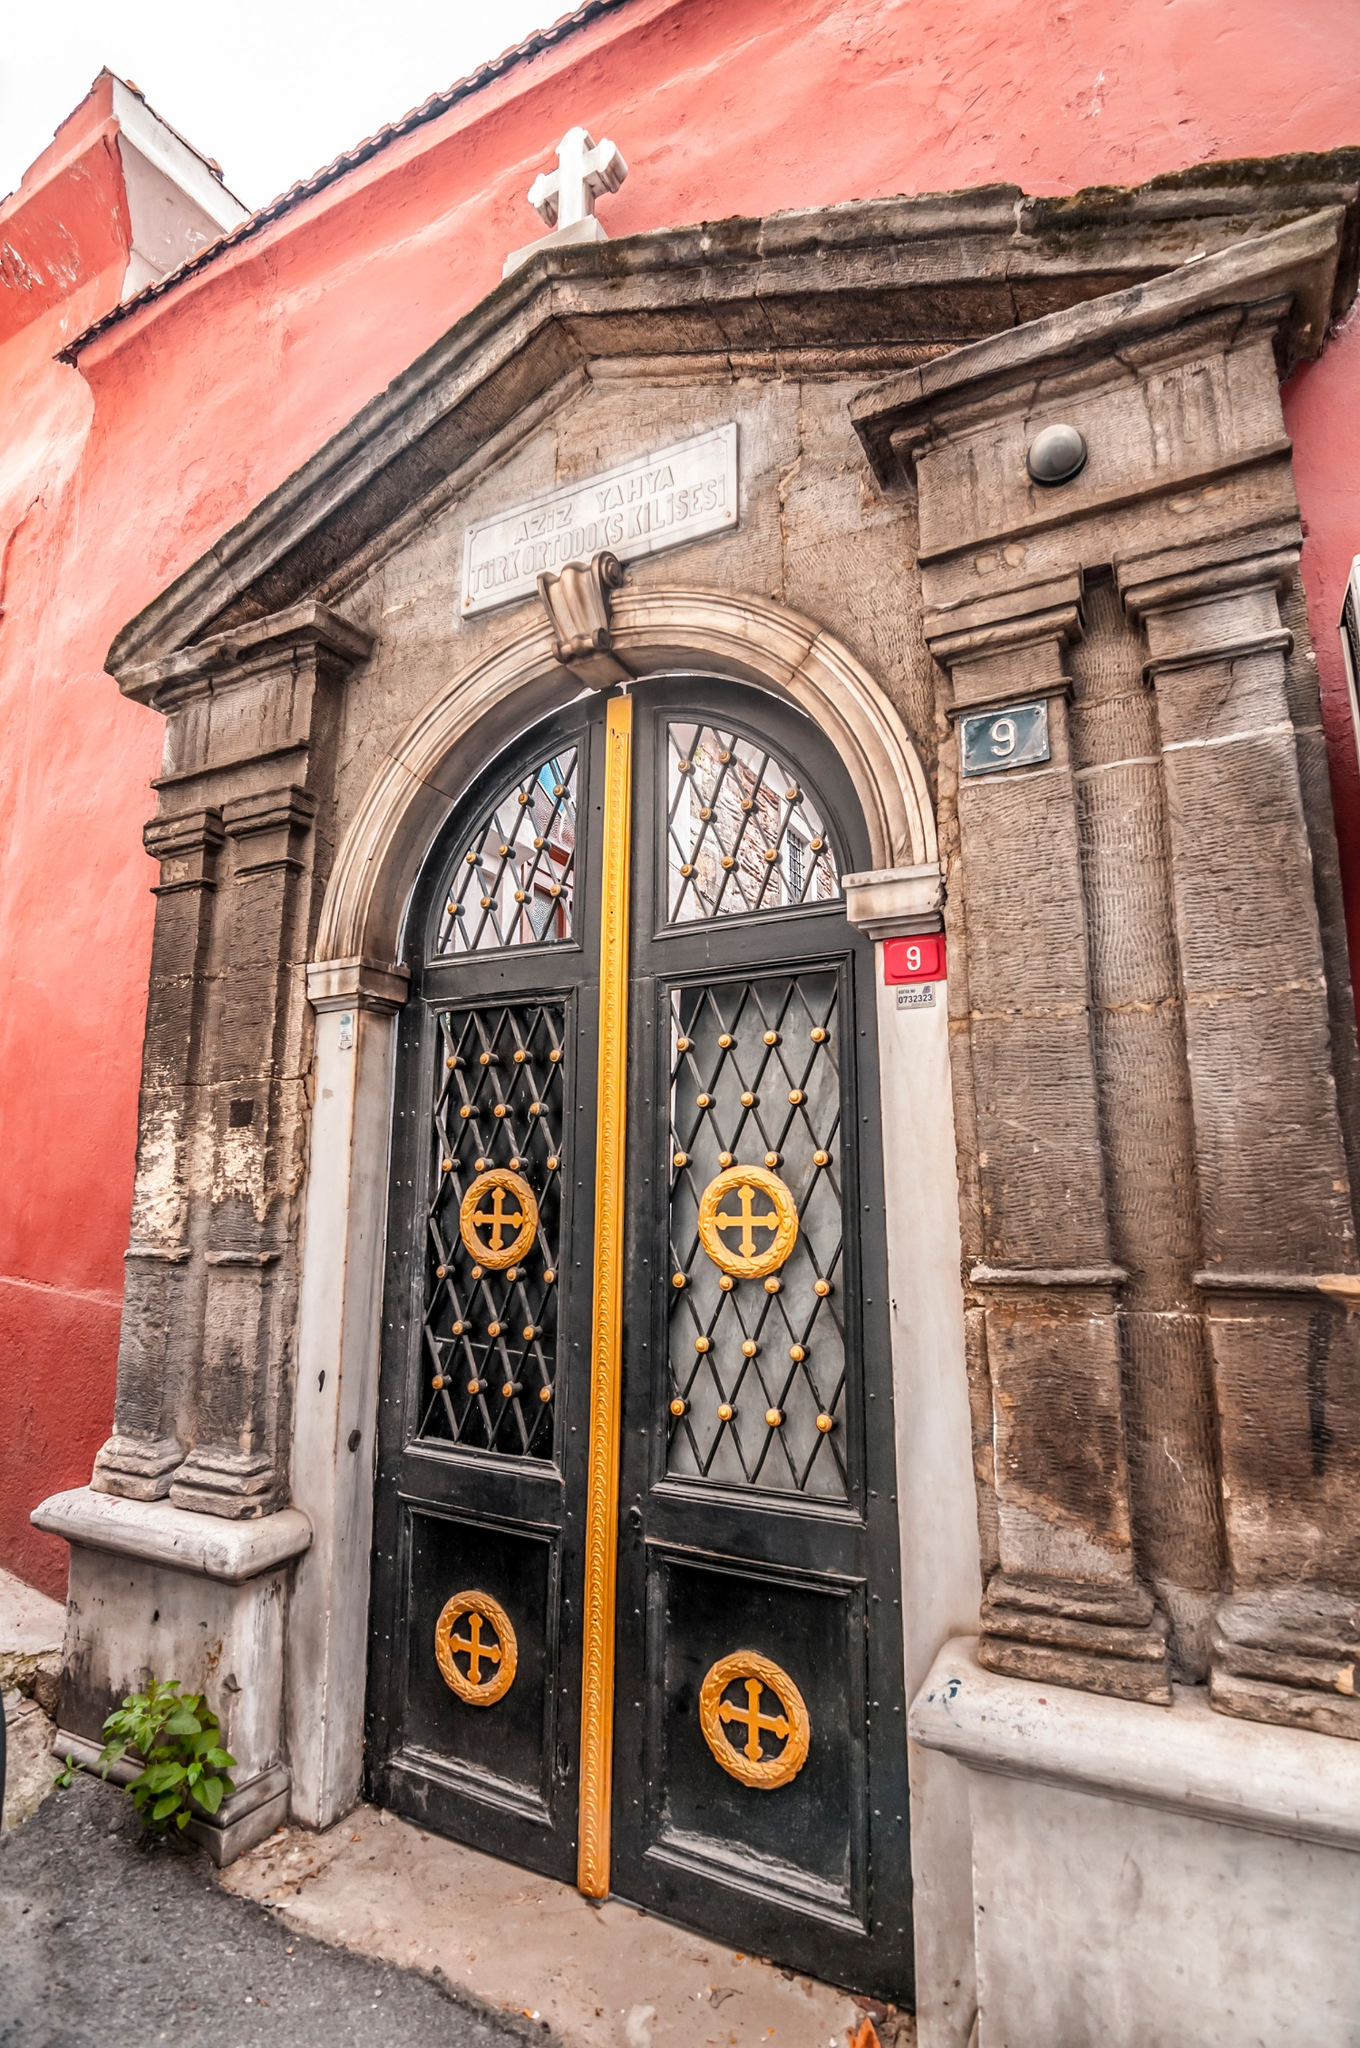Create an imaginative story where this building transforms into something magical at night. As the clock strikes midnight, the stone columns of the building begin to shimmer with a soft, golden light. Slowly, the solid stone walls dissolve into a translucent veil, revealing an ethereal realm hidden within. The door’s metalwork comes to life, the gold crosses start to glow, and the entire entrance morphs into a gateway to a mystical forest. In this enchanted land, ancient trees whisper secrets of the past, and pathways of light guide souls in search of peace. Pixies dance around the plant by the door, whose leaves now sparkle with dew drops of light. This magical forest is a sanctuary for the spirits of those who once worshiped here, offering them a timeless haven. 